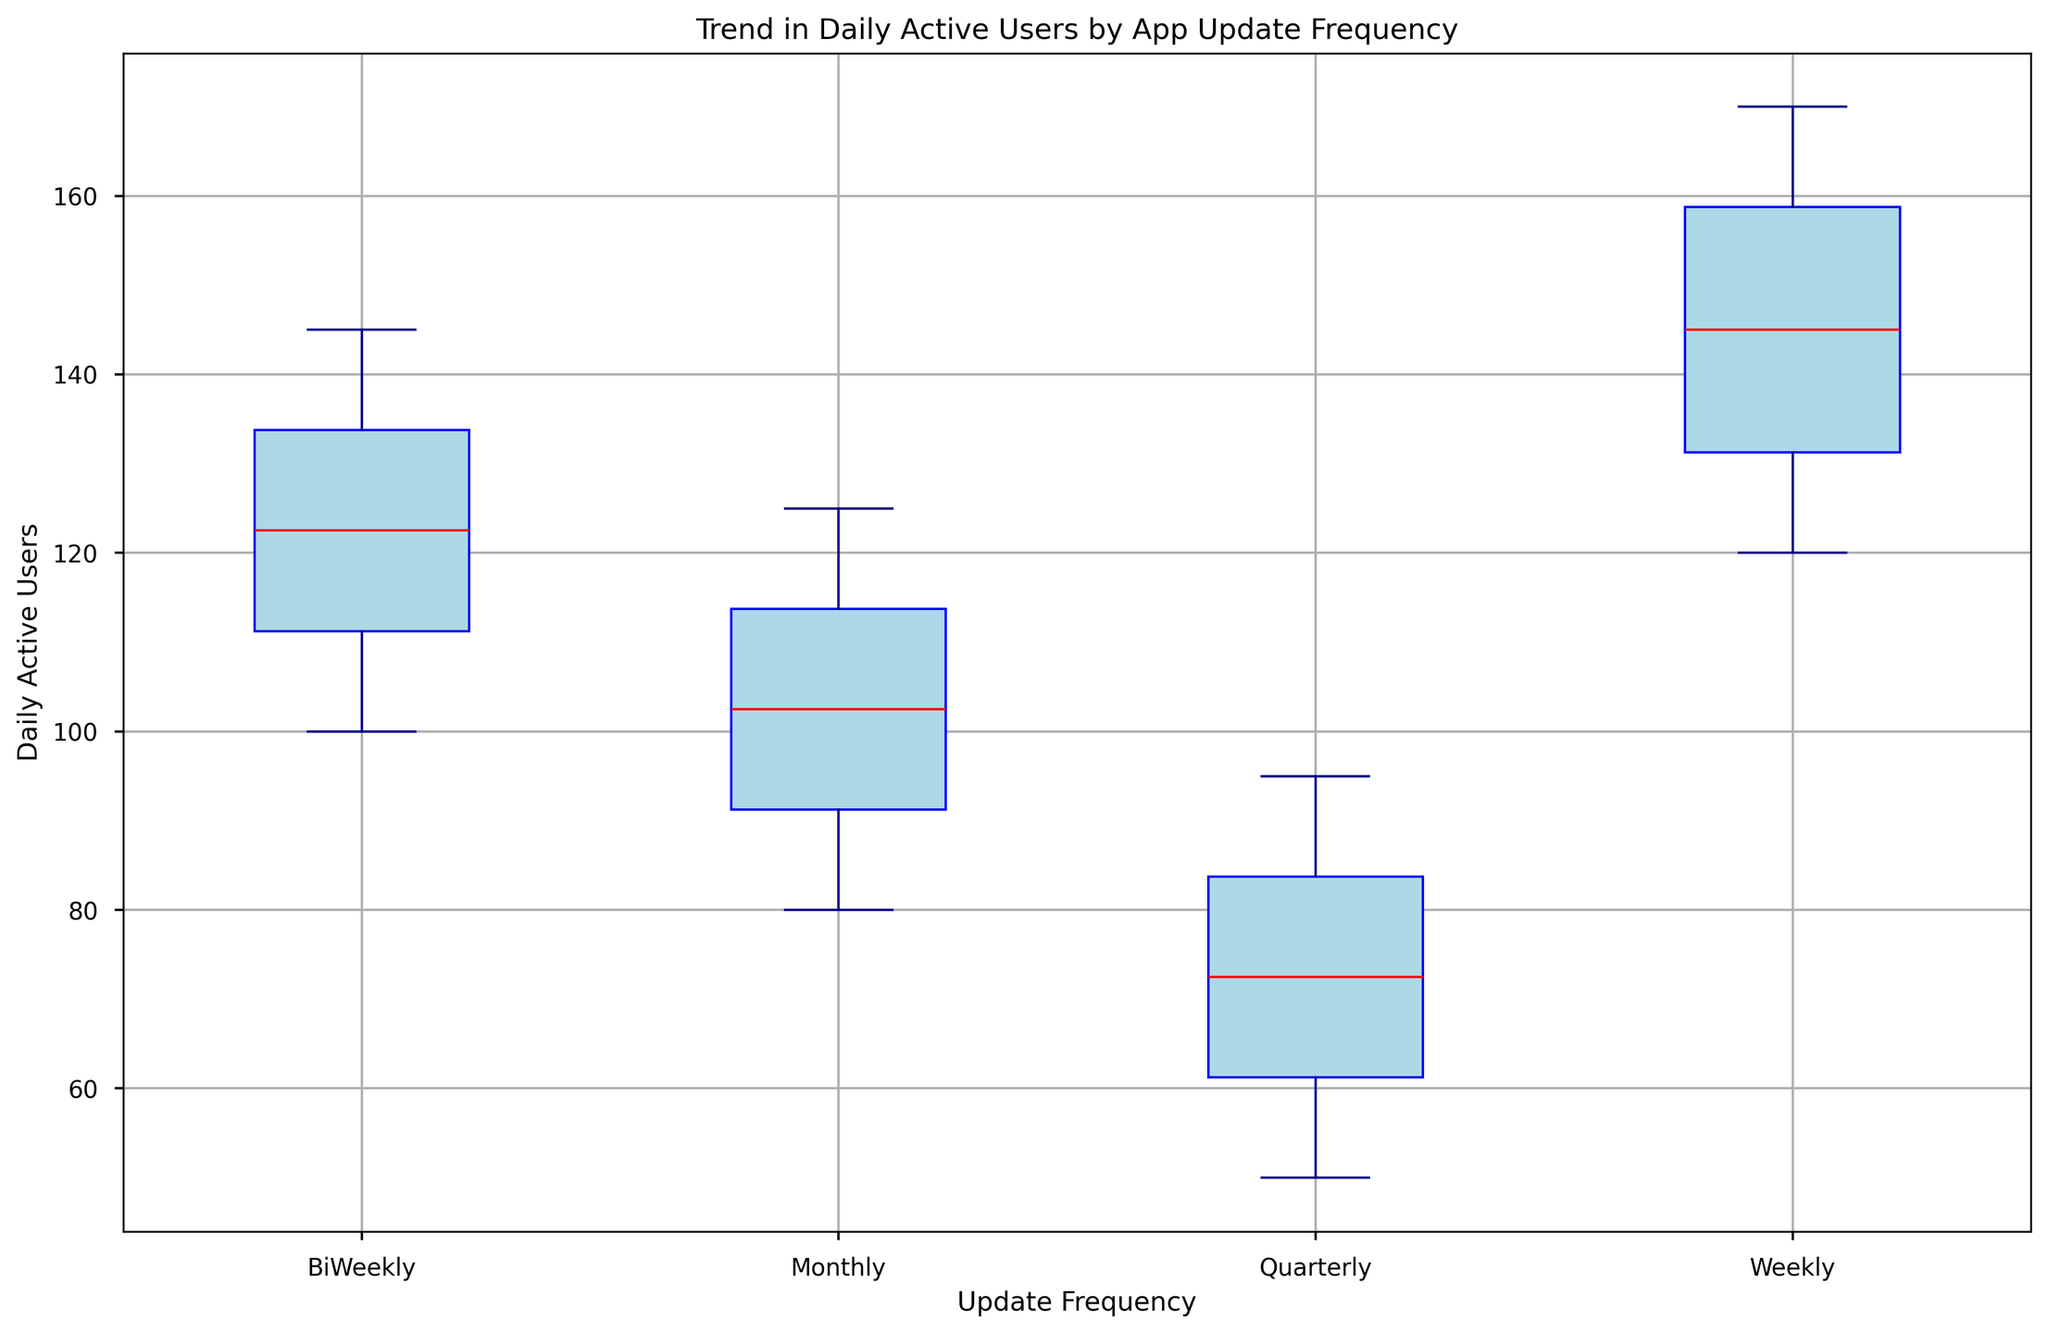What's the median value of Daily Active Users for the Weekly update frequency? The median value can be found by looking at the central line within the box for the Weekly update frequency.
Answer: 140 Which update frequency has the highest median value of Daily Active Users? Compare the central lines within the boxes of each update frequency. The highest median value appears in the Weekly update frequency box.
Answer: Weekly How does the interquartile range (IQR) of the Monthly updates compare to the Quarterly updates? The IQR can be visualized as the height of the box. The Monthly update frequency's box is taller than the Quarterly update frequency's box, indicating a larger IQR.
Answer: Monthly has a larger IQR What is the range of Daily Active Users for the BiWeekly update frequency? The range is the difference between the maximum and minimum values, represented by the top and bottom whiskers. The maximum is 145 and the minimum is 100 for the BiWeekly updates; thus, the range is 145 - 100 = 45.
Answer: 45 Which update frequency shows the smallest number of outliers in Daily Active Users? Look for points outside the whiskers; the Weekly, Monthly, and Quarterly updates appear to have no clear outliers, with BiWeekly having the green points as possible outliers.
Answer: Weekly/Monthly/Quarterly Between Weekly and BiWeekly update frequencies, which has a higher third quartile (75th percentile) for Daily Active Users? The third quartile is the top edge of the box. The Weekly update frequency shows a higher third quartile compared to the BiWeekly update frequency.
Answer: Weekly What is the color used to indicate the median value in the box plot? The median value is indicated by a red line in the boxes.
Answer: Red Which update frequency shows the greatest spread in Daily Active Users? The greatest spread is indicated by the largest distance between the whiskers. The Weekly update frequency has the largest spread.
Answer: Weekly How do the median values of Monthly and Quarterly update frequencies compare? Compare the central lines within the boxes. The Monthly update frequency has a higher median value compared to the Quarterly update frequency.
Answer: Monthly 